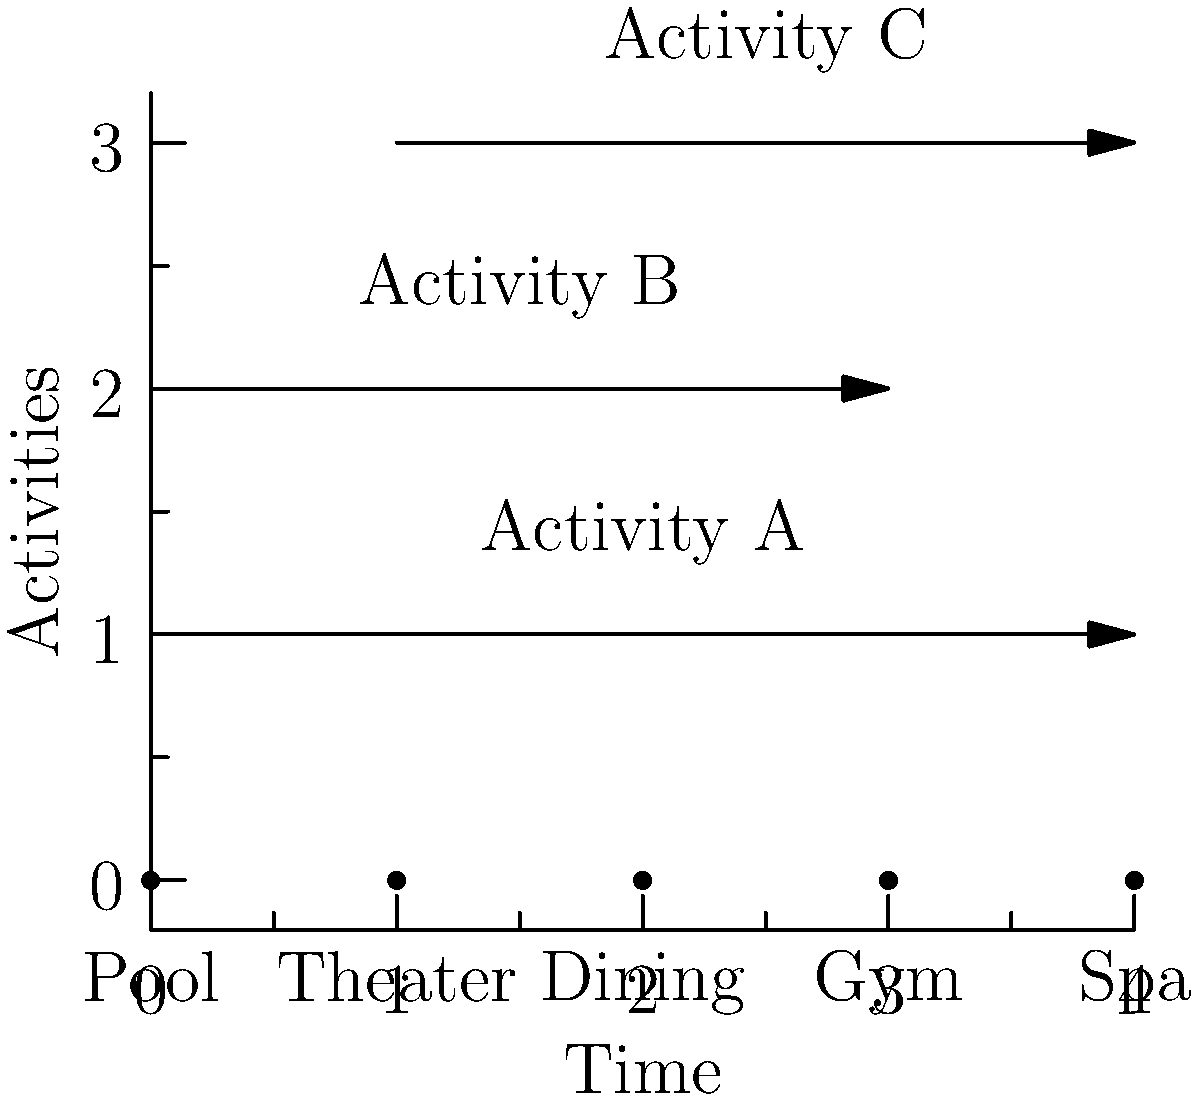As a cruise director, you're planning activities for an anniversary couple. The diagram shows three activities (A, B, and C) scheduled across different ship locations. What is the maximum number of activities the couple can fully participate in without any overlap? Let's analyze the activities step-by-step:

1. Activity A spans from the Pool to the Spa, covering all 5 locations.
2. Activity B starts at the Pool and ends at the Gym, covering 4 locations.
3. Activity C begins at the Theater and ends at the Spa, covering 4 locations.

To determine the maximum number of non-overlapping activities:

1. We can't choose Activity A with any other activity as it overlaps with both B and C.
2. If we don't choose A, we can look at the combination of B and C.
3. Activity B and C overlap at the Theater and Dining locations.

Therefore, the couple can only participate in one activity fully without any overlap. They have three options:
1. Participate in Activity A
2. Participate in Activity B
3. Participate in Activity C

The maximum number of activities they can fully participate in without overlap is 1.
Answer: 1 